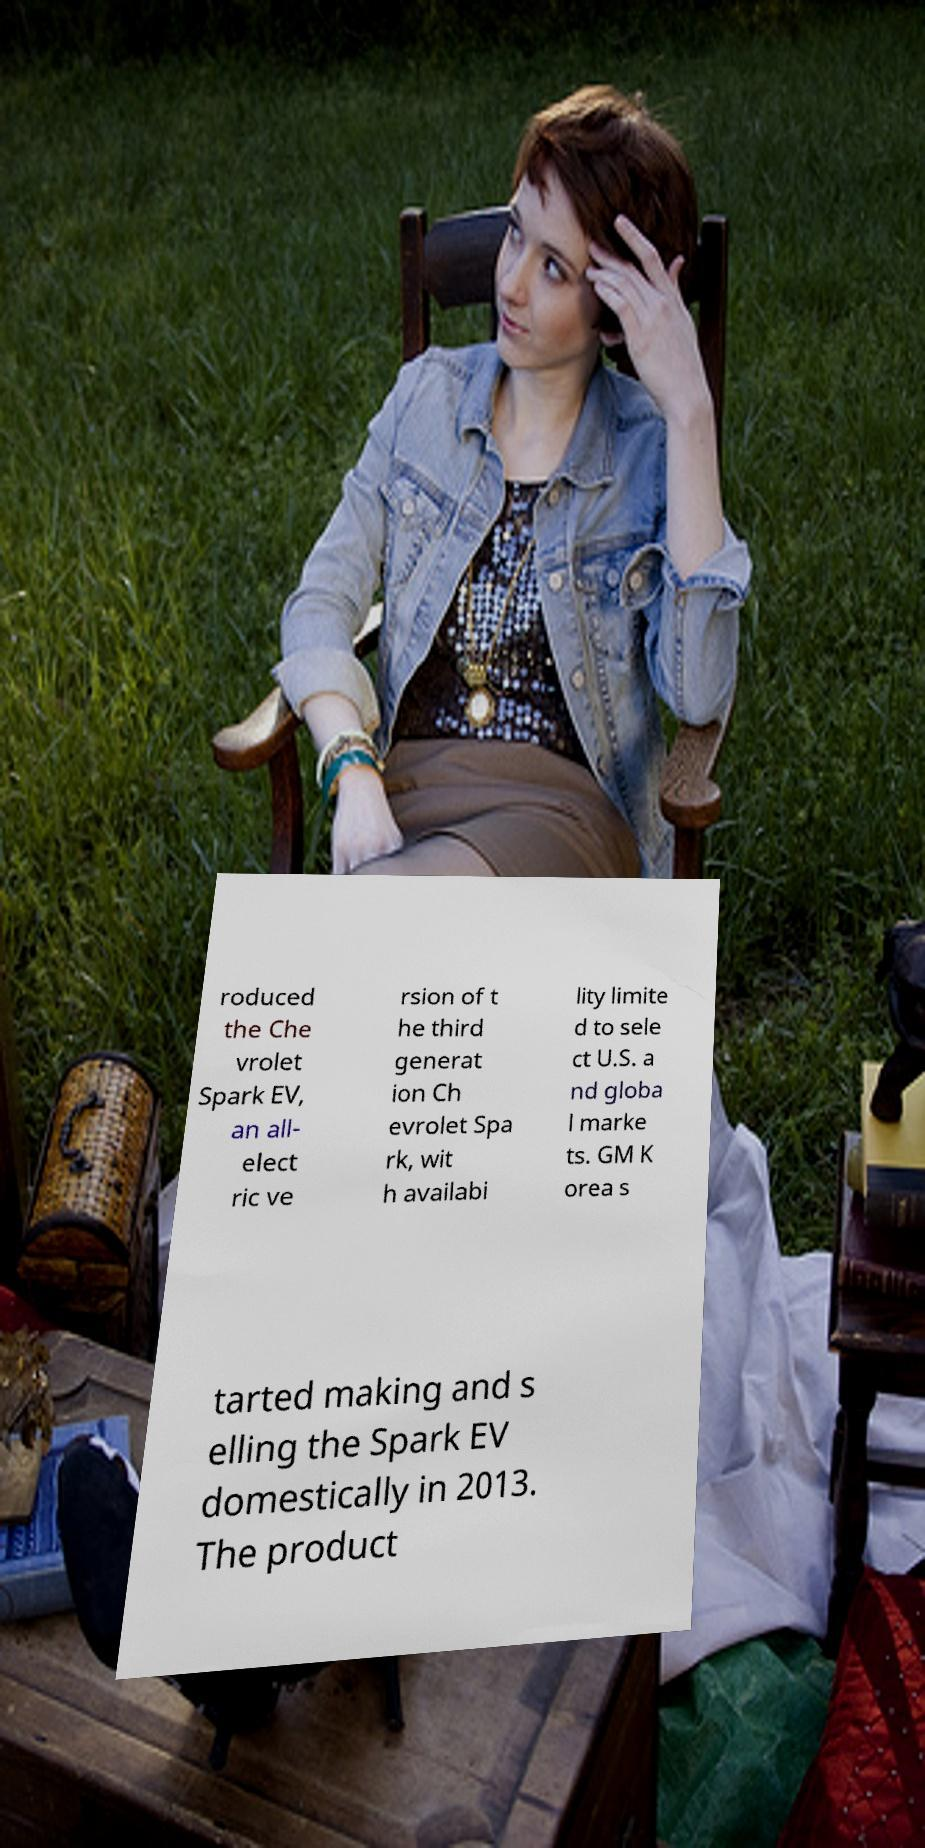What messages or text are displayed in this image? I need them in a readable, typed format. roduced the Che vrolet Spark EV, an all- elect ric ve rsion of t he third generat ion Ch evrolet Spa rk, wit h availabi lity limite d to sele ct U.S. a nd globa l marke ts. GM K orea s tarted making and s elling the Spark EV domestically in 2013. The product 